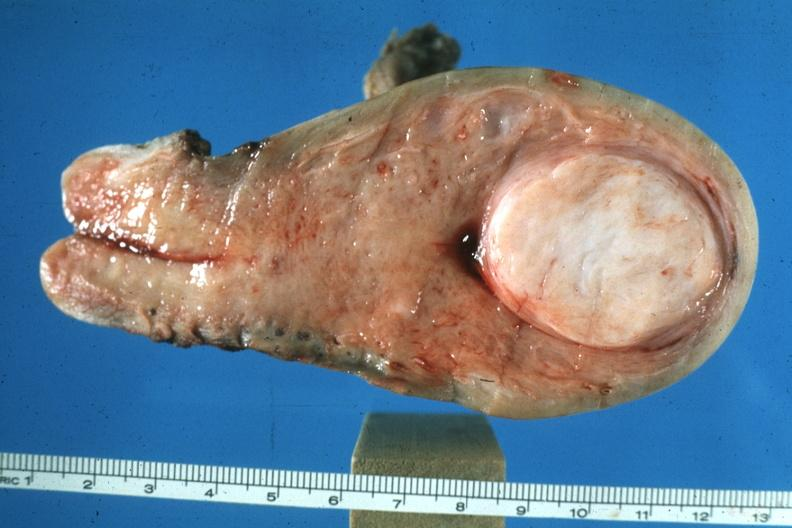s leiomyoma present?
Answer the question using a single word or phrase. Yes 